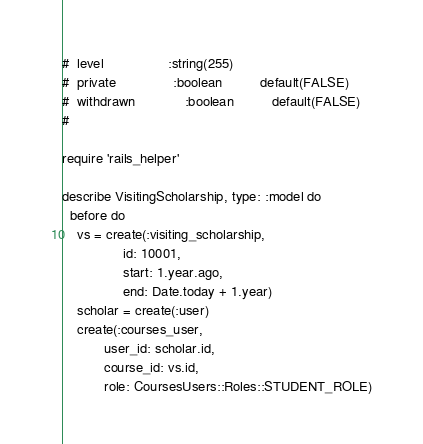Convert code to text. <code><loc_0><loc_0><loc_500><loc_500><_Ruby_>#  level                 :string(255)
#  private               :boolean          default(FALSE)
#  withdrawn             :boolean          default(FALSE)
#

require 'rails_helper'

describe VisitingScholarship, type: :model do
  before do
    vs = create(:visiting_scholarship,
                id: 10001,
                start: 1.year.ago,
                end: Date.today + 1.year)
    scholar = create(:user)
    create(:courses_user,
           user_id: scholar.id,
           course_id: vs.id,
           role: CoursesUsers::Roles::STUDENT_ROLE)</code> 